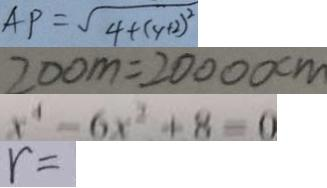Convert formula to latex. <formula><loc_0><loc_0><loc_500><loc_500>A P = \sqrt { 4 + ( y + 2 ) ^ { 2 } } 
 2 0 0 m = 2 0 0 0 0 c m 
 x ^ { 4 } - 6 x ^ { 2 } + 8 = 0 
 r =</formula> 